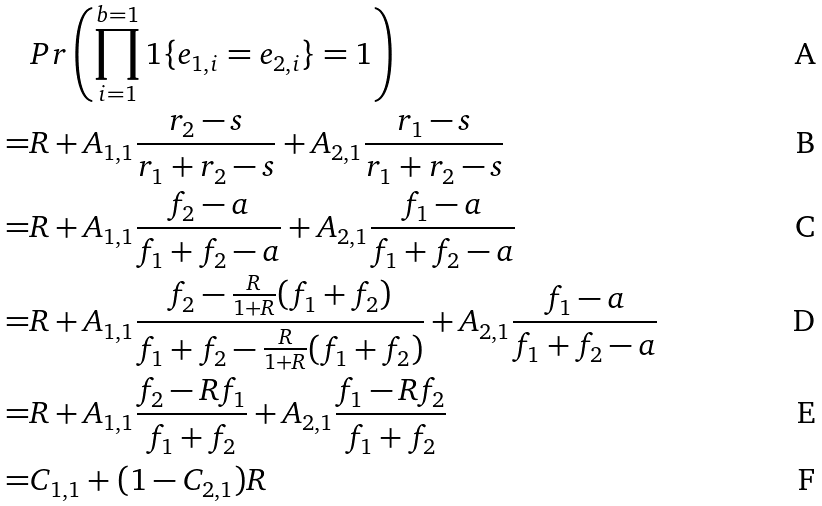<formula> <loc_0><loc_0><loc_500><loc_500>& P r \left ( \prod _ { i = 1 } ^ { b = 1 } 1 \{ e _ { 1 , i } = e _ { 2 , i } \} = 1 \right ) \\ = & R + A _ { 1 , 1 } \frac { r _ { 2 } - s } { r _ { 1 } + r _ { 2 } - s } + A _ { 2 , 1 } \frac { r _ { 1 } - s } { r _ { 1 } + r _ { 2 } - s } \\ = & R + A _ { 1 , 1 } \frac { f _ { 2 } - a } { f _ { 1 } + f _ { 2 } - a } + A _ { 2 , 1 } \frac { f _ { 1 } - a } { f _ { 1 } + f _ { 2 } - a } \\ = & R + A _ { 1 , 1 } \frac { f _ { 2 } - \frac { R } { 1 + R } ( f _ { 1 } + f _ { 2 } ) } { f _ { 1 } + f _ { 2 } - \frac { R } { 1 + R } ( f _ { 1 } + f _ { 2 } ) } + A _ { 2 , 1 } \frac { f _ { 1 } - a } { f _ { 1 } + f _ { 2 } - a } \\ = & R + A _ { 1 , 1 } \frac { f _ { 2 } - R f _ { 1 } } { f _ { 1 } + f _ { 2 } } + A _ { 2 , 1 } \frac { f _ { 1 } - R f _ { 2 } } { f _ { 1 } + f _ { 2 } } \\ = & C _ { 1 , 1 } + ( 1 - C _ { 2 , 1 } ) R</formula> 